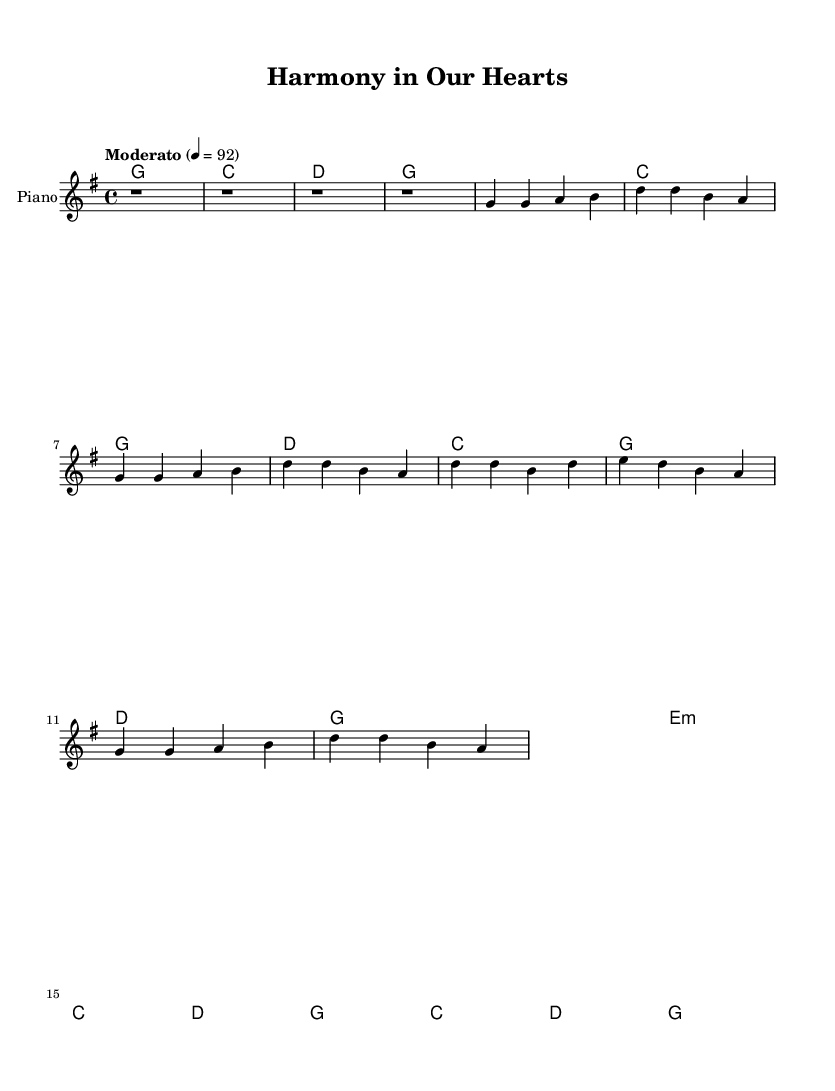What is the key signature of this music? The key signature is indicated at the beginning of the score. In this case, it shows one sharp (F#), so the key is G major.
Answer: G major What is the time signature of this music? The time signature is displayed at the start of the sheet music. It shows a "4/4" which means there are four beats in a measure and the quarter note gets one beat.
Answer: 4/4 What is the tempo marking for this piece? The tempo marking is typically placed under the header. Here it states "Moderato," with a metronome marking of 92 bpm, indicating the speed of the music.
Answer: Moderato How many measures are in the verse section? The verse consists of 4 lines in the lyrics, each corresponding to a set of melodic notes. Counting these, we see there are 8 measures in total for the verse; each line has 2 measures.
Answer: 8 What type of chords are predominantly used in the harmonies? The chord mode shows the chords used throughout the music. Most chords in this piece are major chords (G, C, D), indicating a major tonality typical for uplifting music.
Answer: Major What are the main themes of the lyrics? The lyrics express themes of community, love, and peace which are reflected in the phrasing and word choice. The focus is on unity and harmony among people in a peaceful town.
Answer: Community, peace What music genre does this piece belong to? The structure and lyrical themes indicate this piece is a Blues song, specifically celebrating community and peace, which is commonly seen in gospel-inspired blues.
Answer: Blues 